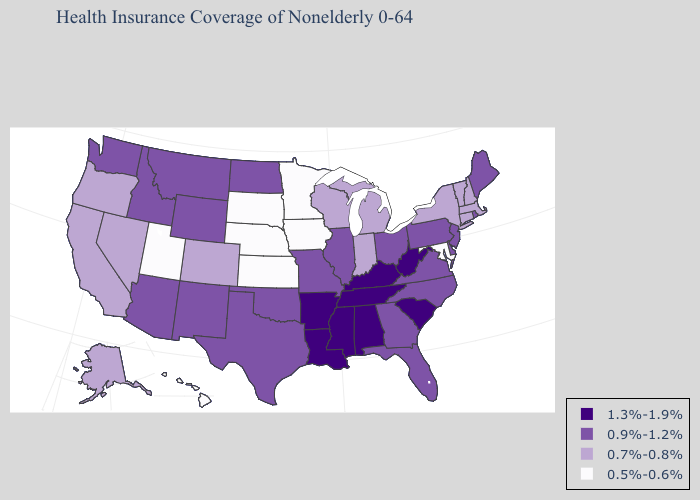Name the states that have a value in the range 0.5%-0.6%?
Short answer required. Hawaii, Iowa, Kansas, Maryland, Minnesota, Nebraska, South Dakota, Utah. Name the states that have a value in the range 1.3%-1.9%?
Short answer required. Alabama, Arkansas, Kentucky, Louisiana, Mississippi, South Carolina, Tennessee, West Virginia. Which states have the lowest value in the South?
Be succinct. Maryland. What is the lowest value in states that border Oregon?
Give a very brief answer. 0.7%-0.8%. Does Maine have the lowest value in the USA?
Be succinct. No. Name the states that have a value in the range 0.7%-0.8%?
Write a very short answer. Alaska, California, Colorado, Connecticut, Indiana, Massachusetts, Michigan, Nevada, New Hampshire, New York, Oregon, Vermont, Wisconsin. Among the states that border Texas , which have the lowest value?
Be succinct. New Mexico, Oklahoma. What is the lowest value in the USA?
Give a very brief answer. 0.5%-0.6%. Does Kentucky have the highest value in the USA?
Give a very brief answer. Yes. Among the states that border Virginia , which have the lowest value?
Write a very short answer. Maryland. What is the value of North Carolina?
Be succinct. 0.9%-1.2%. Which states have the lowest value in the USA?
Concise answer only. Hawaii, Iowa, Kansas, Maryland, Minnesota, Nebraska, South Dakota, Utah. Does Idaho have the lowest value in the USA?
Be succinct. No. What is the highest value in states that border West Virginia?
Be succinct. 1.3%-1.9%. Which states have the lowest value in the MidWest?
Concise answer only. Iowa, Kansas, Minnesota, Nebraska, South Dakota. 